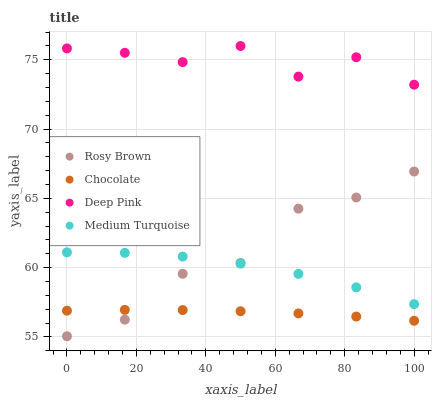Does Chocolate have the minimum area under the curve?
Answer yes or no. Yes. Does Deep Pink have the maximum area under the curve?
Answer yes or no. Yes. Does Medium Turquoise have the minimum area under the curve?
Answer yes or no. No. Does Medium Turquoise have the maximum area under the curve?
Answer yes or no. No. Is Chocolate the smoothest?
Answer yes or no. Yes. Is Deep Pink the roughest?
Answer yes or no. Yes. Is Medium Turquoise the smoothest?
Answer yes or no. No. Is Medium Turquoise the roughest?
Answer yes or no. No. Does Rosy Brown have the lowest value?
Answer yes or no. Yes. Does Medium Turquoise have the lowest value?
Answer yes or no. No. Does Deep Pink have the highest value?
Answer yes or no. Yes. Does Medium Turquoise have the highest value?
Answer yes or no. No. Is Chocolate less than Medium Turquoise?
Answer yes or no. Yes. Is Deep Pink greater than Chocolate?
Answer yes or no. Yes. Does Chocolate intersect Rosy Brown?
Answer yes or no. Yes. Is Chocolate less than Rosy Brown?
Answer yes or no. No. Is Chocolate greater than Rosy Brown?
Answer yes or no. No. Does Chocolate intersect Medium Turquoise?
Answer yes or no. No. 